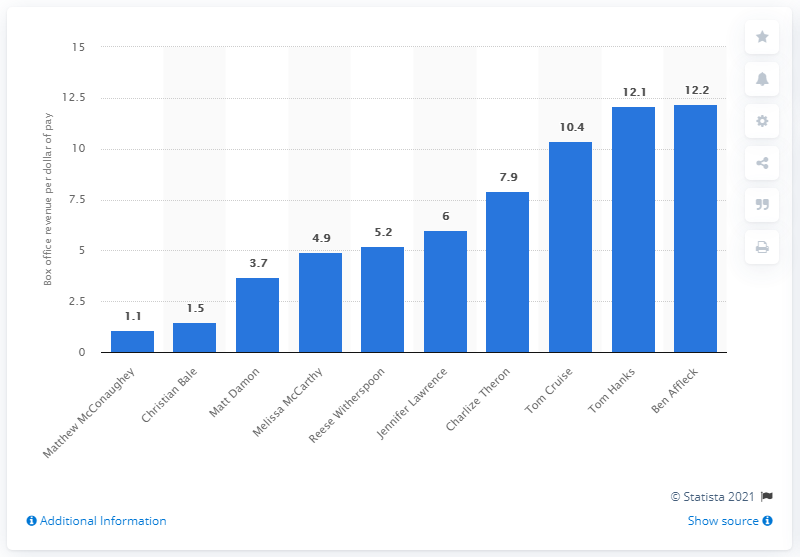Which actor ranked second on the list with 1.5 dollars per dollar of his pay? Christian Bale is the actor who ranks second on this list, earning a remarkable $1.5 for each dollar paid to him. His consistent performances in high-grossing films contribute to this impressive box office return on investment. 